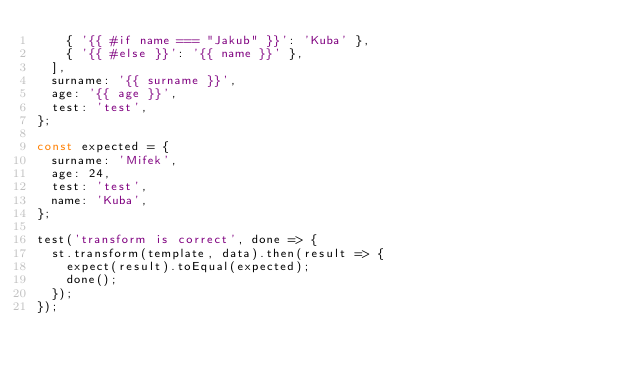<code> <loc_0><loc_0><loc_500><loc_500><_JavaScript_>    { '{{ #if name === "Jakub" }}': 'Kuba' },
    { '{{ #else }}': '{{ name }}' },
  ],
  surname: '{{ surname }}',
  age: '{{ age }}',
  test: 'test',
};

const expected = {
  surname: 'Mifek',
  age: 24,
  test: 'test',
  name: 'Kuba',
};

test('transform is correct', done => {
  st.transform(template, data).then(result => {
    expect(result).toEqual(expected);
    done();
  });
});
</code> 